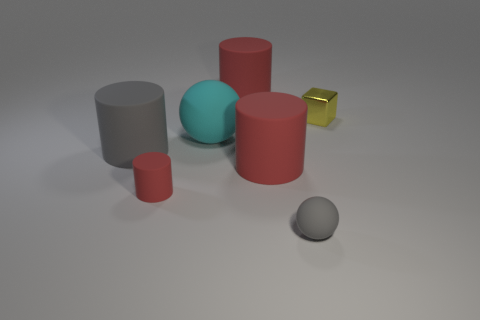Subtract all small matte cylinders. How many cylinders are left? 3 Add 1 gray matte objects. How many objects exist? 8 Subtract all red cylinders. How many cylinders are left? 1 Subtract all yellow spheres. How many red cylinders are left? 3 Subtract all blue cylinders. Subtract all blue cubes. How many cylinders are left? 4 Subtract 0 red blocks. How many objects are left? 7 Subtract all balls. How many objects are left? 5 Subtract 2 cylinders. How many cylinders are left? 2 Subtract all small objects. Subtract all gray rubber cylinders. How many objects are left? 3 Add 5 small rubber objects. How many small rubber objects are left? 7 